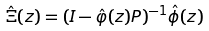<formula> <loc_0><loc_0><loc_500><loc_500>\hat { \Xi } ( z ) = ( I - \hat { \varphi } ( z ) P ) ^ { - 1 } \hat { \phi } ( z )</formula> 